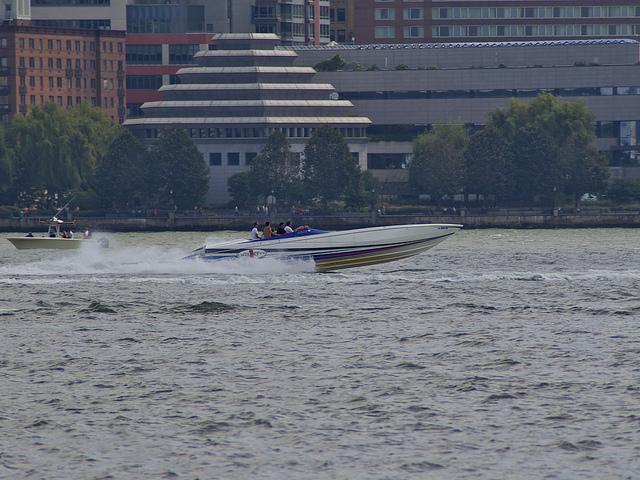How many people are on the boat?
Short answer required. 4. Are there lights on the boat?
Concise answer only. No. What kind of hat is the man on the boat wearing?
Quick response, please. None. Is the building pyramid-shaped?
Write a very short answer. Yes. Is the boat in the water?
Be succinct. Yes. 